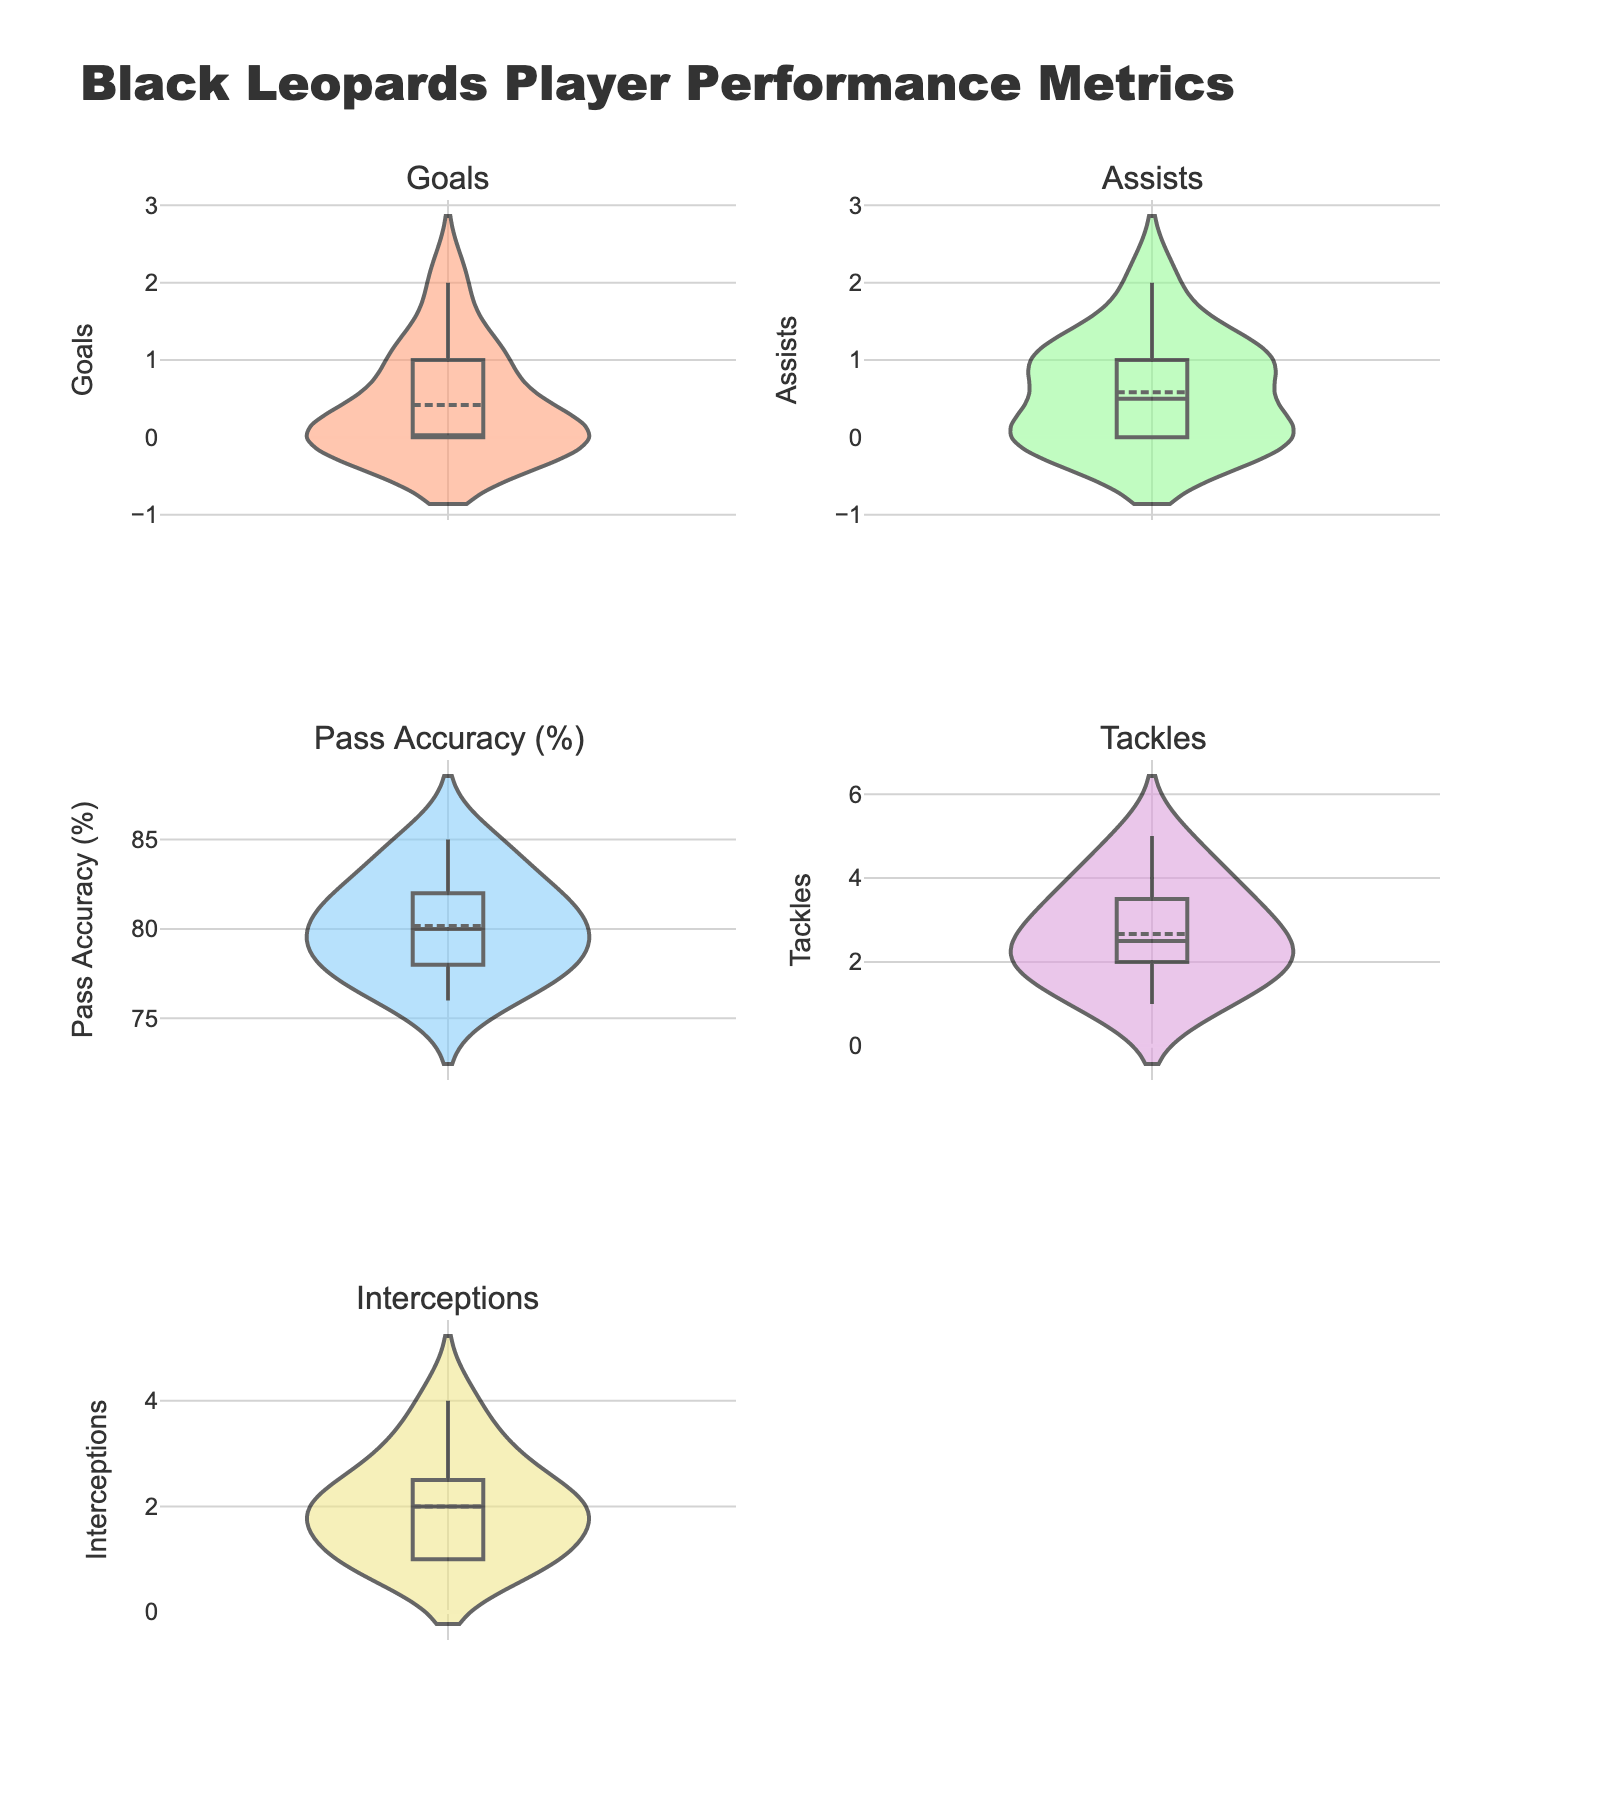What's the title of the figure? The title of the figure is displayed at the top, written prominently in larger font.
Answer: Black Leopards Player Performance Metrics How many subplots are there in the figure? The figure is divided into multiple smaller plots that show different performance metrics. You can count these smaller plots.
Answer: 5 Which metric has the highest number of violin plots? Each subplot corresponds to a metric, and within each subplot, the metric being visualized is shown.
Answer: All metrics have an equal number of violin plots (1 each) Which metric is shown in the top-left subplot? The order of the subplots follows a left-to-right, top-to-bottom sequence. The titles above the subplots indicate the metrics. The top-left subplot corresponds to the metric displayed there.
Answer: Goals What's the mean Pass Accuracy (%) in the data? The mean line in the violin plot for Pass Accuracy (%) shows the average pass accuracy for the players.
Answer: Around 80% Which metric shows the greatest variation? By observing the width of the violin plots, you can see where the values are more spread out.
Answer: Tackles Comparing Goals and Assists, which one has a higher median value? The median value is shown by the thick line in the middle of the violin plot. Compare the median lines for Goals and Assists.
Answer: Assists Which metric's violin plot has the smallest interquartile range? The interquartile range can be assessed by the distance between the quartiles represented within the violin plot. A smaller interquartile range will have a narrower main section of the plot.
Answer: Interceptions How many subplots have their y-axis labeled? Look at each subplot's vertical axis to see if there is a metric label indicating what the axis represents. Count all labeled y-axes.
Answer: 5 In which metric's plot is the mean line closest to the median line? Compare the violin plots to see where the mean line (if marked) is aligning closely with the thick median line inside the plot.
Answer: Pass Accuracy (%) 